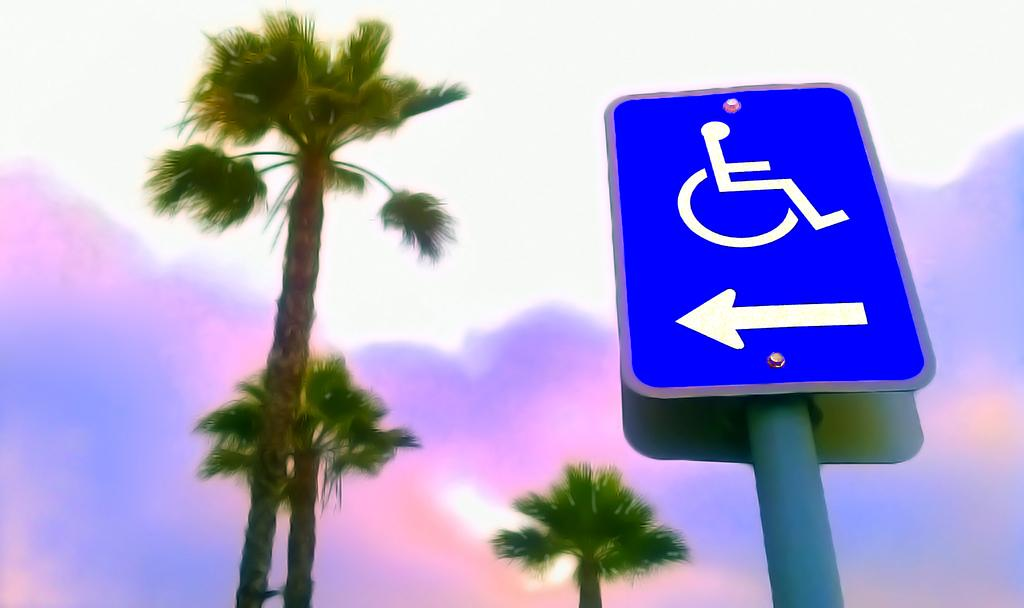What is on the pole in the image? There is a signboard on the pole in the image. What type of trees are near the pole? There are coconut trees beside the pole. What can be seen in the background of the image? The sky is visible in the image. What is the condition of the sky in the image? Clouds are present in the sky. How many stomachs does the jellyfish in the image have? There is no jellyfish present in the image; it features a pole with a signboard and coconut trees. 